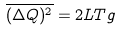Convert formula to latex. <formula><loc_0><loc_0><loc_500><loc_500>\overline { ( \Delta Q ) ^ { 2 } } = { 2 L T } g</formula> 